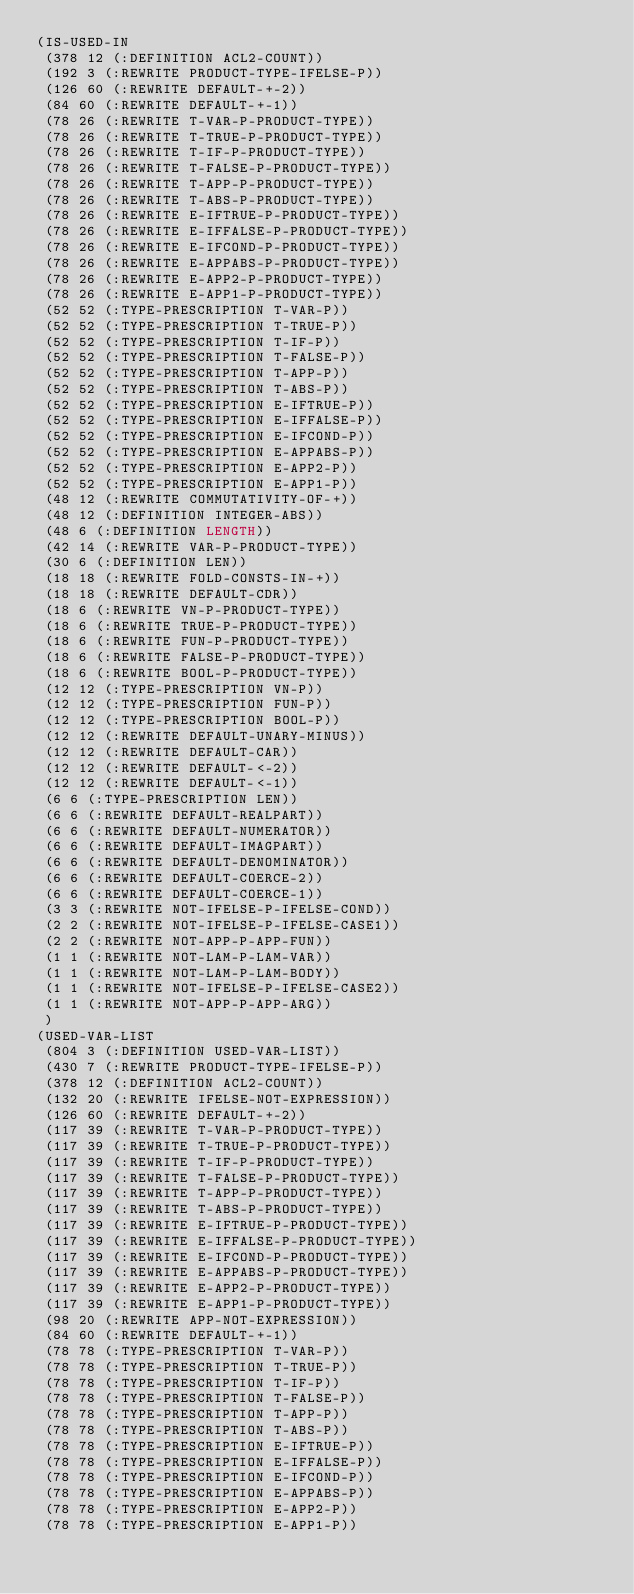Convert code to text. <code><loc_0><loc_0><loc_500><loc_500><_Lisp_>(IS-USED-IN
 (378 12 (:DEFINITION ACL2-COUNT))
 (192 3 (:REWRITE PRODUCT-TYPE-IFELSE-P))
 (126 60 (:REWRITE DEFAULT-+-2))
 (84 60 (:REWRITE DEFAULT-+-1))
 (78 26 (:REWRITE T-VAR-P-PRODUCT-TYPE))
 (78 26 (:REWRITE T-TRUE-P-PRODUCT-TYPE))
 (78 26 (:REWRITE T-IF-P-PRODUCT-TYPE))
 (78 26 (:REWRITE T-FALSE-P-PRODUCT-TYPE))
 (78 26 (:REWRITE T-APP-P-PRODUCT-TYPE))
 (78 26 (:REWRITE T-ABS-P-PRODUCT-TYPE))
 (78 26 (:REWRITE E-IFTRUE-P-PRODUCT-TYPE))
 (78 26 (:REWRITE E-IFFALSE-P-PRODUCT-TYPE))
 (78 26 (:REWRITE E-IFCOND-P-PRODUCT-TYPE))
 (78 26 (:REWRITE E-APPABS-P-PRODUCT-TYPE))
 (78 26 (:REWRITE E-APP2-P-PRODUCT-TYPE))
 (78 26 (:REWRITE E-APP1-P-PRODUCT-TYPE))
 (52 52 (:TYPE-PRESCRIPTION T-VAR-P))
 (52 52 (:TYPE-PRESCRIPTION T-TRUE-P))
 (52 52 (:TYPE-PRESCRIPTION T-IF-P))
 (52 52 (:TYPE-PRESCRIPTION T-FALSE-P))
 (52 52 (:TYPE-PRESCRIPTION T-APP-P))
 (52 52 (:TYPE-PRESCRIPTION T-ABS-P))
 (52 52 (:TYPE-PRESCRIPTION E-IFTRUE-P))
 (52 52 (:TYPE-PRESCRIPTION E-IFFALSE-P))
 (52 52 (:TYPE-PRESCRIPTION E-IFCOND-P))
 (52 52 (:TYPE-PRESCRIPTION E-APPABS-P))
 (52 52 (:TYPE-PRESCRIPTION E-APP2-P))
 (52 52 (:TYPE-PRESCRIPTION E-APP1-P))
 (48 12 (:REWRITE COMMUTATIVITY-OF-+))
 (48 12 (:DEFINITION INTEGER-ABS))
 (48 6 (:DEFINITION LENGTH))
 (42 14 (:REWRITE VAR-P-PRODUCT-TYPE))
 (30 6 (:DEFINITION LEN))
 (18 18 (:REWRITE FOLD-CONSTS-IN-+))
 (18 18 (:REWRITE DEFAULT-CDR))
 (18 6 (:REWRITE VN-P-PRODUCT-TYPE))
 (18 6 (:REWRITE TRUE-P-PRODUCT-TYPE))
 (18 6 (:REWRITE FUN-P-PRODUCT-TYPE))
 (18 6 (:REWRITE FALSE-P-PRODUCT-TYPE))
 (18 6 (:REWRITE BOOL-P-PRODUCT-TYPE))
 (12 12 (:TYPE-PRESCRIPTION VN-P))
 (12 12 (:TYPE-PRESCRIPTION FUN-P))
 (12 12 (:TYPE-PRESCRIPTION BOOL-P))
 (12 12 (:REWRITE DEFAULT-UNARY-MINUS))
 (12 12 (:REWRITE DEFAULT-CAR))
 (12 12 (:REWRITE DEFAULT-<-2))
 (12 12 (:REWRITE DEFAULT-<-1))
 (6 6 (:TYPE-PRESCRIPTION LEN))
 (6 6 (:REWRITE DEFAULT-REALPART))
 (6 6 (:REWRITE DEFAULT-NUMERATOR))
 (6 6 (:REWRITE DEFAULT-IMAGPART))
 (6 6 (:REWRITE DEFAULT-DENOMINATOR))
 (6 6 (:REWRITE DEFAULT-COERCE-2))
 (6 6 (:REWRITE DEFAULT-COERCE-1))
 (3 3 (:REWRITE NOT-IFELSE-P-IFELSE-COND))
 (2 2 (:REWRITE NOT-IFELSE-P-IFELSE-CASE1))
 (2 2 (:REWRITE NOT-APP-P-APP-FUN))
 (1 1 (:REWRITE NOT-LAM-P-LAM-VAR))
 (1 1 (:REWRITE NOT-LAM-P-LAM-BODY))
 (1 1 (:REWRITE NOT-IFELSE-P-IFELSE-CASE2))
 (1 1 (:REWRITE NOT-APP-P-APP-ARG))
 )
(USED-VAR-LIST
 (804 3 (:DEFINITION USED-VAR-LIST))
 (430 7 (:REWRITE PRODUCT-TYPE-IFELSE-P))
 (378 12 (:DEFINITION ACL2-COUNT))
 (132 20 (:REWRITE IFELSE-NOT-EXPRESSION))
 (126 60 (:REWRITE DEFAULT-+-2))
 (117 39 (:REWRITE T-VAR-P-PRODUCT-TYPE))
 (117 39 (:REWRITE T-TRUE-P-PRODUCT-TYPE))
 (117 39 (:REWRITE T-IF-P-PRODUCT-TYPE))
 (117 39 (:REWRITE T-FALSE-P-PRODUCT-TYPE))
 (117 39 (:REWRITE T-APP-P-PRODUCT-TYPE))
 (117 39 (:REWRITE T-ABS-P-PRODUCT-TYPE))
 (117 39 (:REWRITE E-IFTRUE-P-PRODUCT-TYPE))
 (117 39 (:REWRITE E-IFFALSE-P-PRODUCT-TYPE))
 (117 39 (:REWRITE E-IFCOND-P-PRODUCT-TYPE))
 (117 39 (:REWRITE E-APPABS-P-PRODUCT-TYPE))
 (117 39 (:REWRITE E-APP2-P-PRODUCT-TYPE))
 (117 39 (:REWRITE E-APP1-P-PRODUCT-TYPE))
 (98 20 (:REWRITE APP-NOT-EXPRESSION))
 (84 60 (:REWRITE DEFAULT-+-1))
 (78 78 (:TYPE-PRESCRIPTION T-VAR-P))
 (78 78 (:TYPE-PRESCRIPTION T-TRUE-P))
 (78 78 (:TYPE-PRESCRIPTION T-IF-P))
 (78 78 (:TYPE-PRESCRIPTION T-FALSE-P))
 (78 78 (:TYPE-PRESCRIPTION T-APP-P))
 (78 78 (:TYPE-PRESCRIPTION T-ABS-P))
 (78 78 (:TYPE-PRESCRIPTION E-IFTRUE-P))
 (78 78 (:TYPE-PRESCRIPTION E-IFFALSE-P))
 (78 78 (:TYPE-PRESCRIPTION E-IFCOND-P))
 (78 78 (:TYPE-PRESCRIPTION E-APPABS-P))
 (78 78 (:TYPE-PRESCRIPTION E-APP2-P))
 (78 78 (:TYPE-PRESCRIPTION E-APP1-P))</code> 